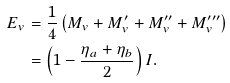Convert formula to latex. <formula><loc_0><loc_0><loc_500><loc_500>E _ { v } & = \frac { 1 } { 4 } \left ( M _ { v } + M ^ { \prime } _ { v } + M ^ { \prime \prime } _ { v } + M ^ { \prime \prime \prime } _ { v } \right ) \\ & = \left ( 1 - \frac { \eta _ { a } + \eta _ { b } } { 2 } \right ) I \text {.}</formula> 